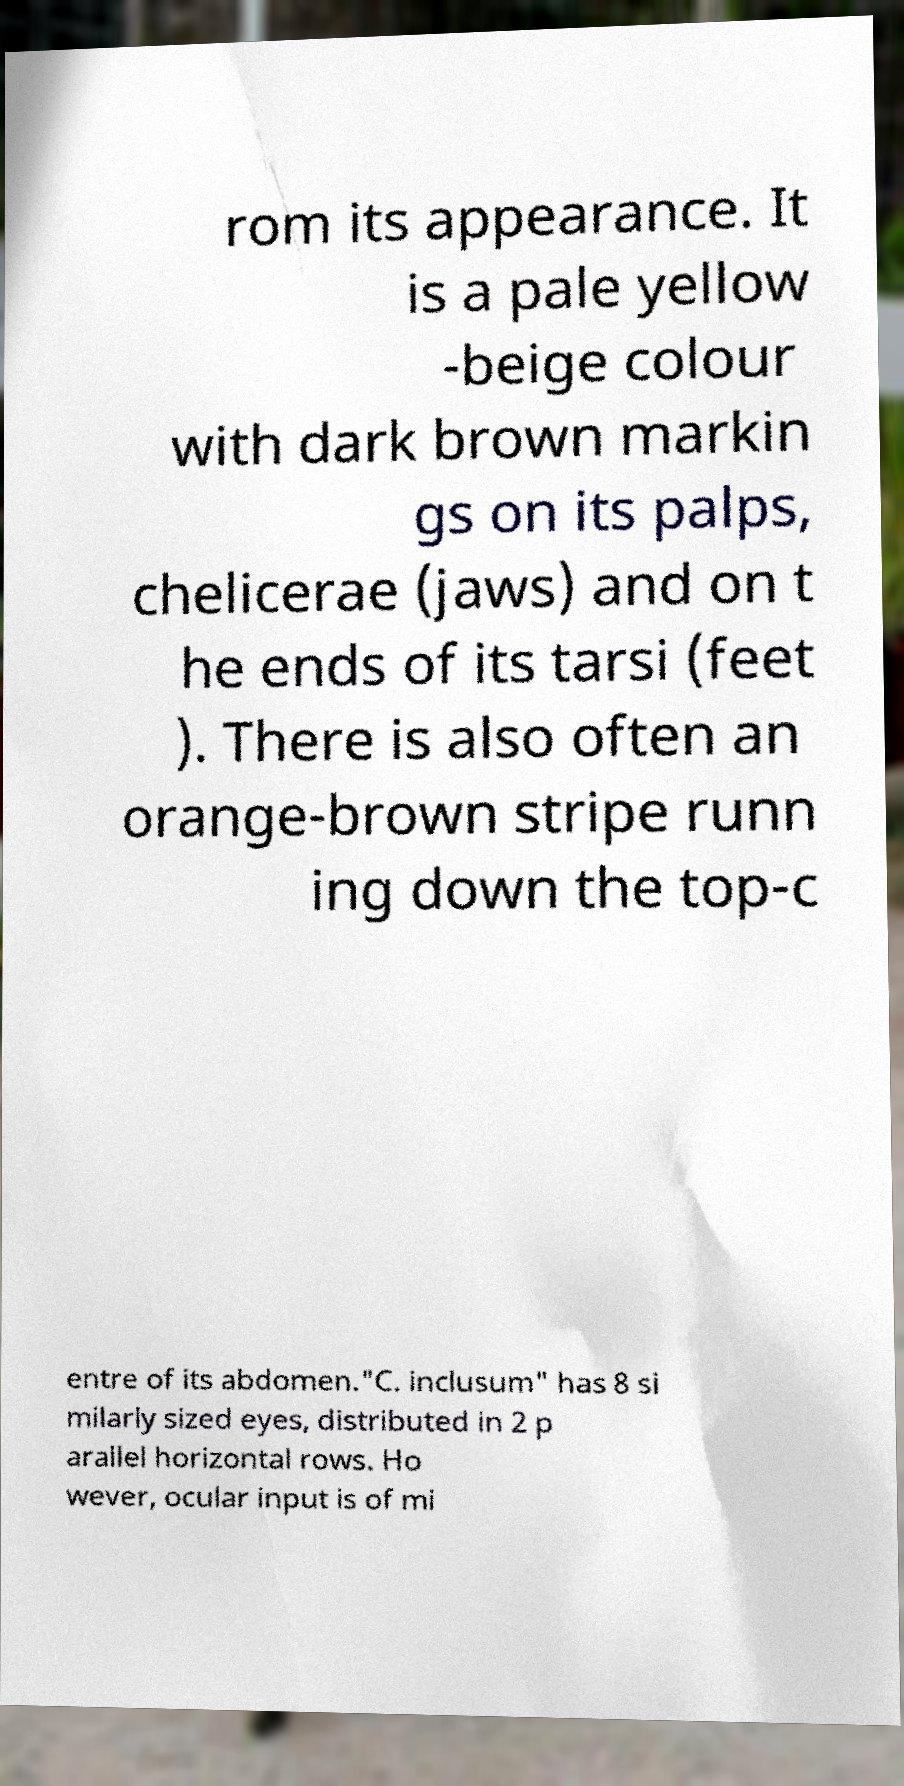Please identify and transcribe the text found in this image. rom its appearance. It is a pale yellow -beige colour with dark brown markin gs on its palps, chelicerae (jaws) and on t he ends of its tarsi (feet ). There is also often an orange-brown stripe runn ing down the top-c entre of its abdomen."C. inclusum" has 8 si milarly sized eyes, distributed in 2 p arallel horizontal rows. Ho wever, ocular input is of mi 